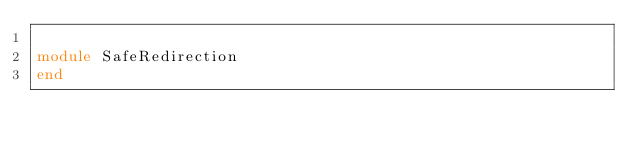<code> <loc_0><loc_0><loc_500><loc_500><_Ruby_>
module SafeRedirection
end
</code> 